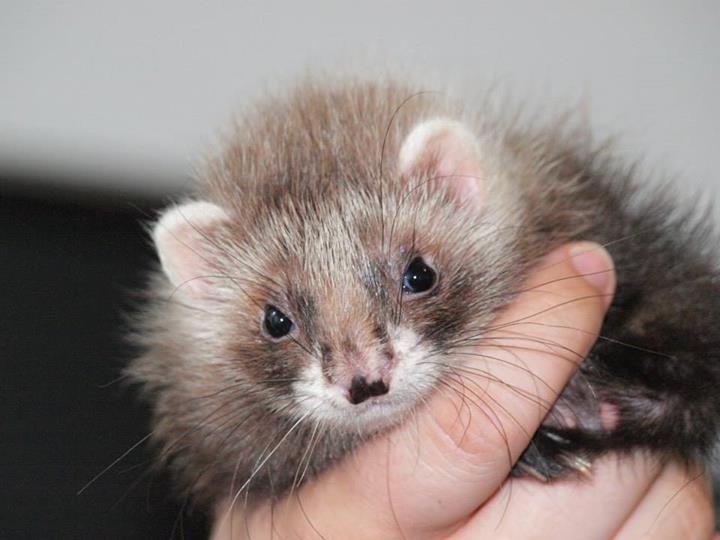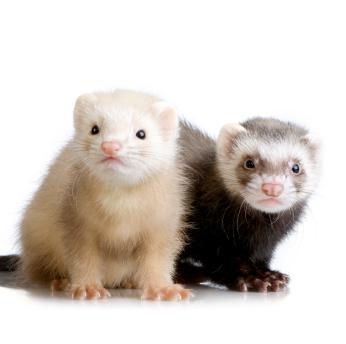The first image is the image on the left, the second image is the image on the right. Given the left and right images, does the statement "There is only one ferret in each of the images." hold true? Answer yes or no. No. The first image is the image on the left, the second image is the image on the right. For the images displayed, is the sentence "One of the images shows an animal being held by a human." factually correct? Answer yes or no. Yes. 